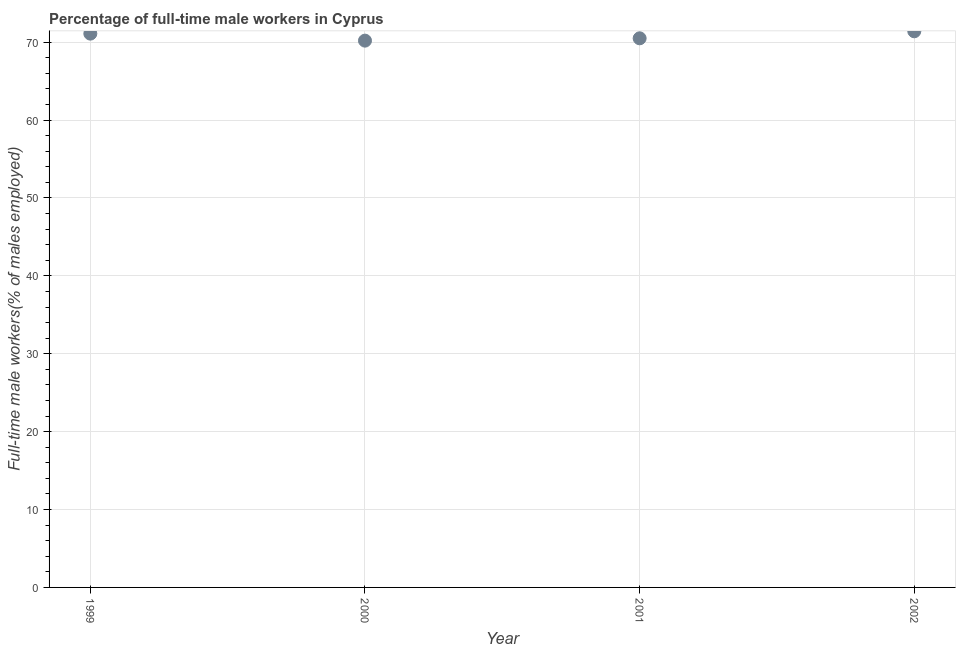What is the percentage of full-time male workers in 2002?
Your answer should be compact. 71.4. Across all years, what is the maximum percentage of full-time male workers?
Offer a very short reply. 71.4. Across all years, what is the minimum percentage of full-time male workers?
Offer a terse response. 70.2. What is the sum of the percentage of full-time male workers?
Your answer should be very brief. 283.2. What is the difference between the percentage of full-time male workers in 2000 and 2001?
Offer a terse response. -0.3. What is the average percentage of full-time male workers per year?
Your answer should be compact. 70.8. What is the median percentage of full-time male workers?
Your response must be concise. 70.8. Do a majority of the years between 2001 and 1999 (inclusive) have percentage of full-time male workers greater than 40 %?
Keep it short and to the point. No. What is the ratio of the percentage of full-time male workers in 1999 to that in 2000?
Your answer should be compact. 1.01. Is the difference between the percentage of full-time male workers in 2000 and 2002 greater than the difference between any two years?
Provide a succinct answer. Yes. What is the difference between the highest and the second highest percentage of full-time male workers?
Keep it short and to the point. 0.3. Is the sum of the percentage of full-time male workers in 1999 and 2000 greater than the maximum percentage of full-time male workers across all years?
Your response must be concise. Yes. What is the difference between the highest and the lowest percentage of full-time male workers?
Your response must be concise. 1.2. Does the percentage of full-time male workers monotonically increase over the years?
Offer a very short reply. No. How many dotlines are there?
Your answer should be compact. 1. How many years are there in the graph?
Keep it short and to the point. 4. What is the difference between two consecutive major ticks on the Y-axis?
Your answer should be compact. 10. Does the graph contain any zero values?
Give a very brief answer. No. What is the title of the graph?
Provide a short and direct response. Percentage of full-time male workers in Cyprus. What is the label or title of the X-axis?
Your answer should be compact. Year. What is the label or title of the Y-axis?
Your answer should be very brief. Full-time male workers(% of males employed). What is the Full-time male workers(% of males employed) in 1999?
Make the answer very short. 71.1. What is the Full-time male workers(% of males employed) in 2000?
Keep it short and to the point. 70.2. What is the Full-time male workers(% of males employed) in 2001?
Provide a short and direct response. 70.5. What is the Full-time male workers(% of males employed) in 2002?
Your answer should be compact. 71.4. What is the difference between the Full-time male workers(% of males employed) in 1999 and 2002?
Your answer should be compact. -0.3. What is the ratio of the Full-time male workers(% of males employed) in 1999 to that in 2002?
Provide a succinct answer. 1. What is the ratio of the Full-time male workers(% of males employed) in 2000 to that in 2002?
Ensure brevity in your answer.  0.98. 